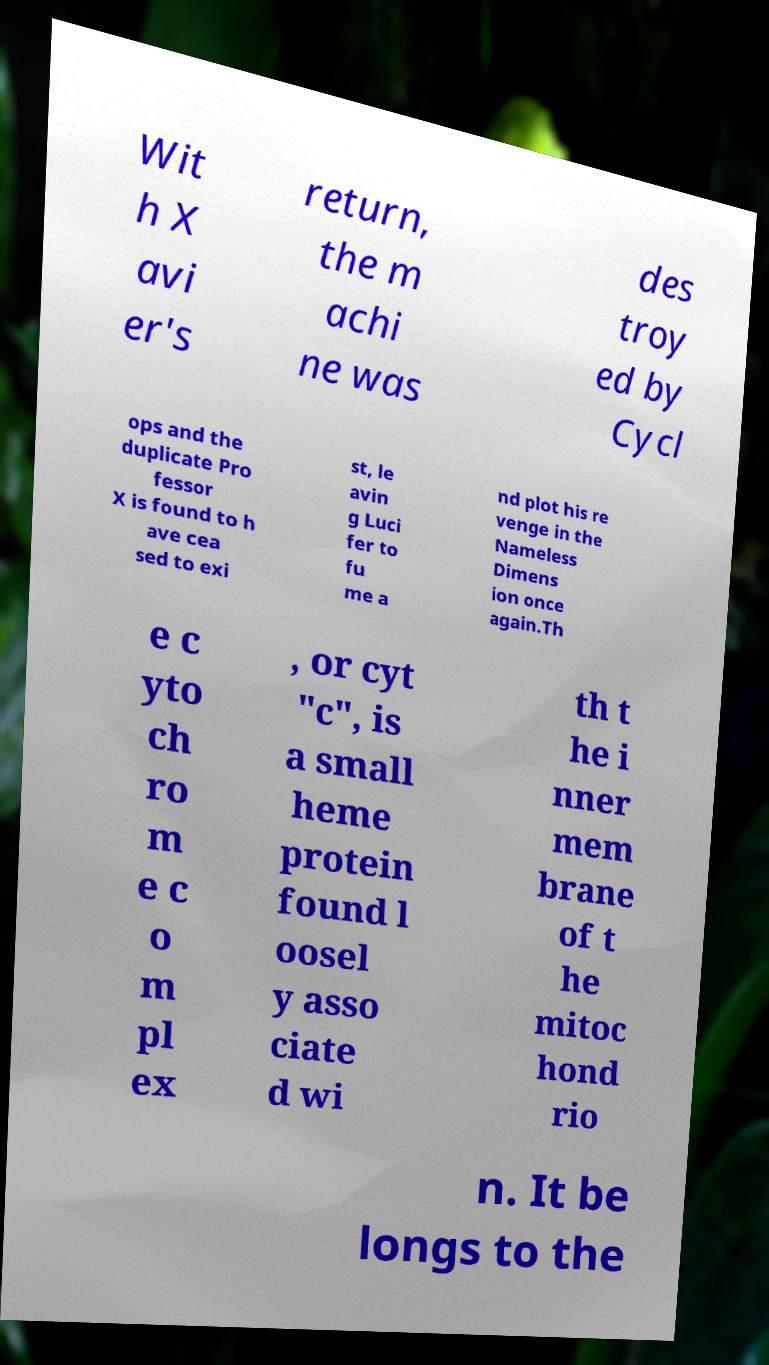For documentation purposes, I need the text within this image transcribed. Could you provide that? Wit h X avi er's return, the m achi ne was des troy ed by Cycl ops and the duplicate Pro fessor X is found to h ave cea sed to exi st, le avin g Luci fer to fu me a nd plot his re venge in the Nameless Dimens ion once again.Th e c yto ch ro m e c o m pl ex , or cyt "c", is a small heme protein found l oosel y asso ciate d wi th t he i nner mem brane of t he mitoc hond rio n. It be longs to the 